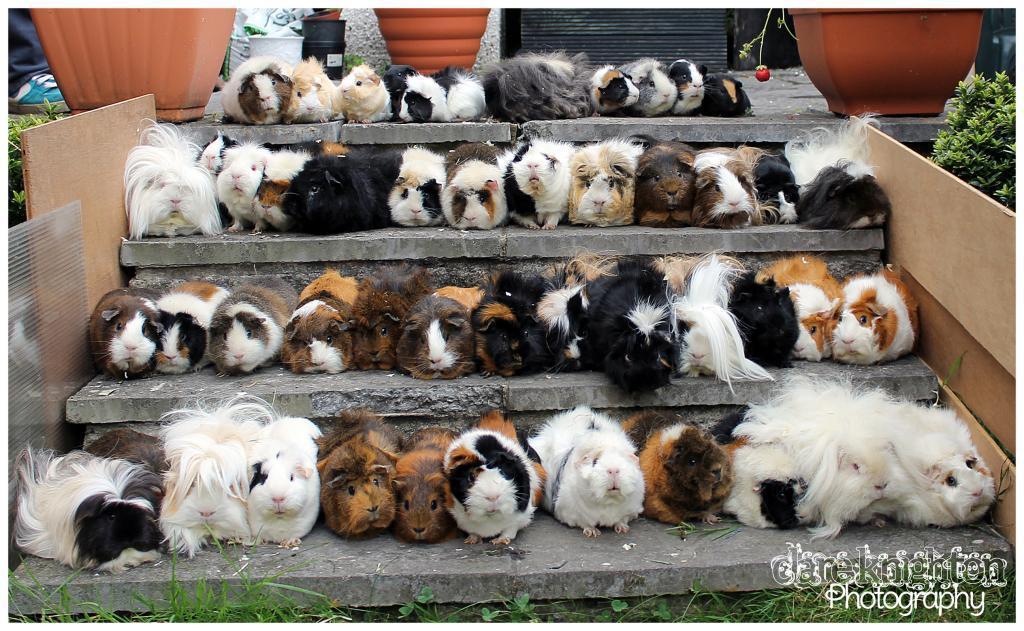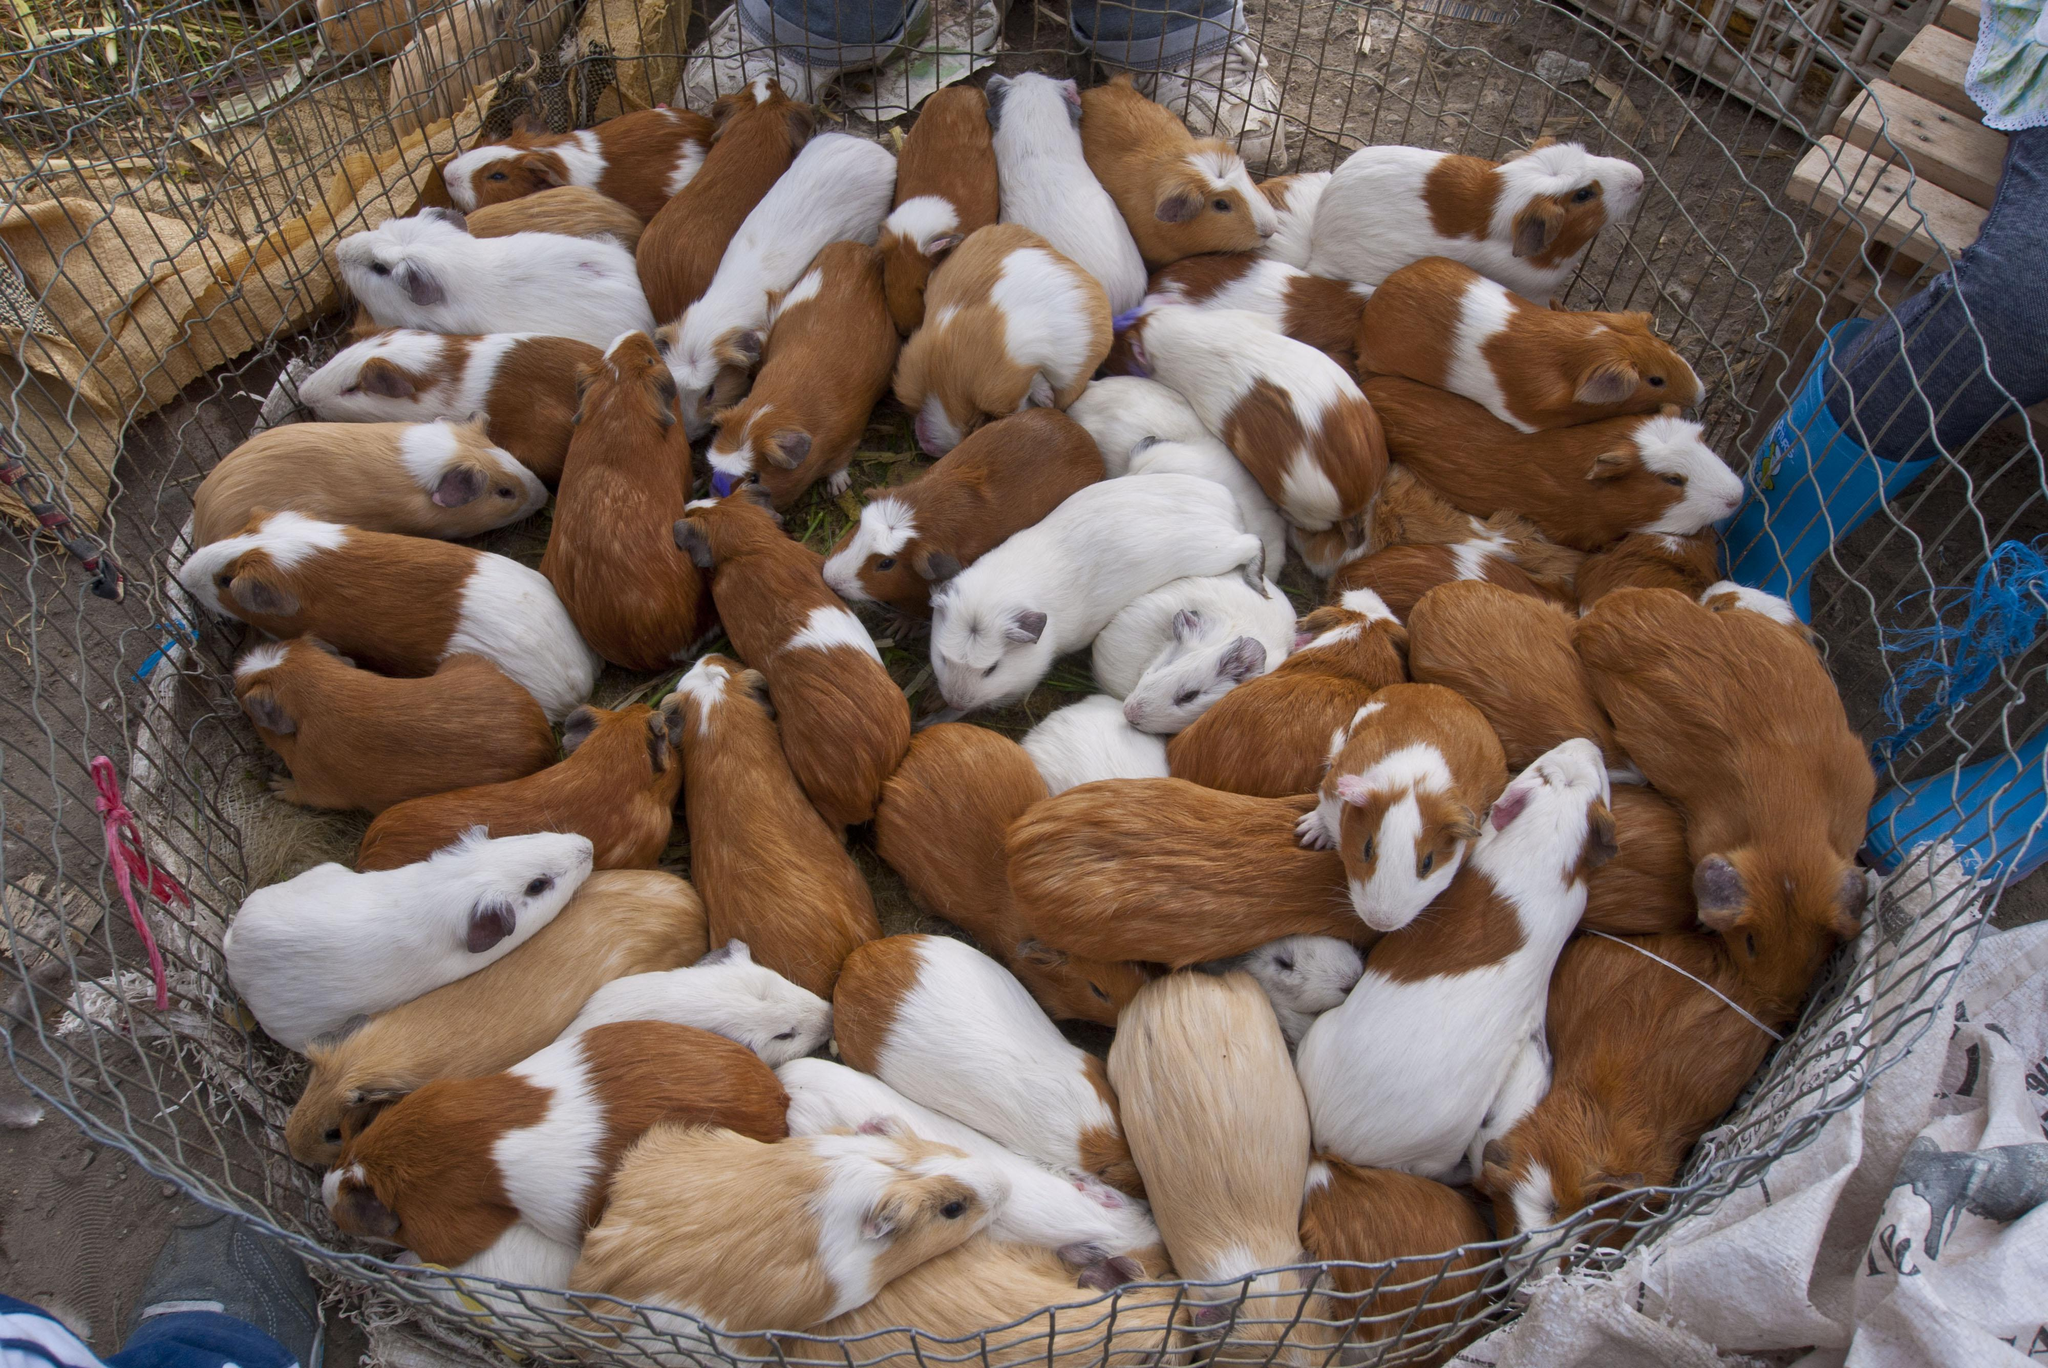The first image is the image on the left, the second image is the image on the right. Assess this claim about the two images: "The animals in the image on the left are not in an enclosure.". Correct or not? Answer yes or no. Yes. 